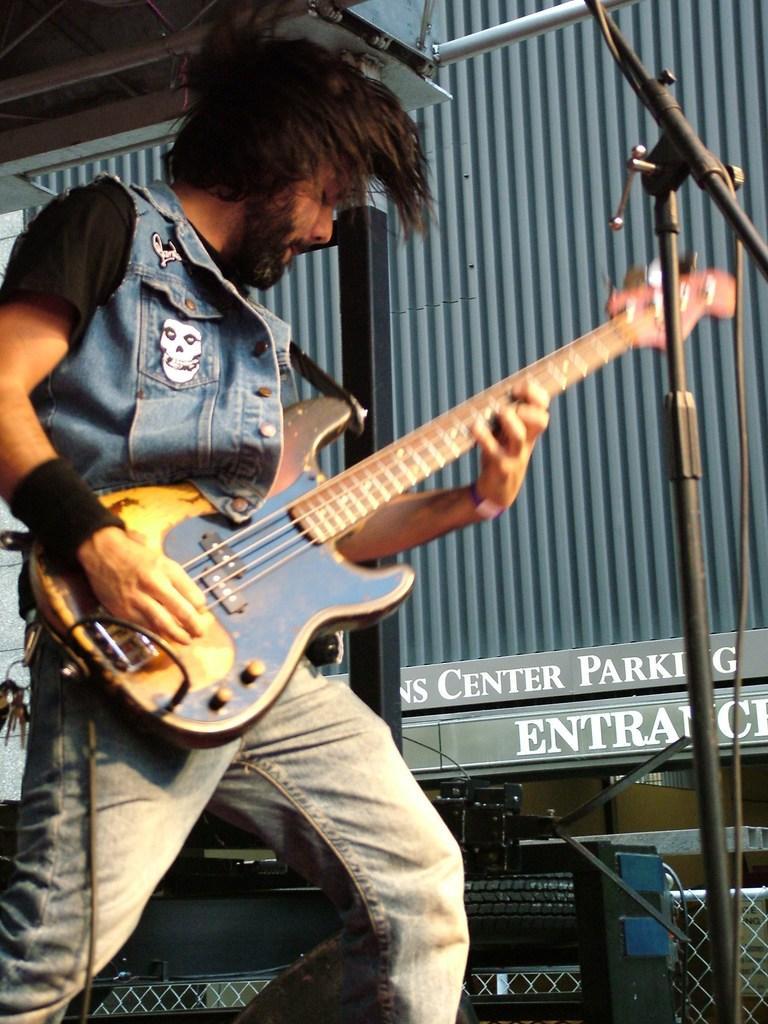How would you summarize this image in a sentence or two? In this image I can see a man wearing jean jacket and trouser. he is wearing a hand band. He is playing guitar. This is a mike stand. I can see a name board which is attached to the building. And I can see some electronic device is placed at bottom of the image. 